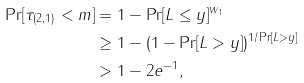Convert formula to latex. <formula><loc_0><loc_0><loc_500><loc_500>\Pr [ \tau _ { ( 2 , 1 ) } < m ] & = 1 - \Pr [ L \leq y ] ^ { w _ { 1 } } \\ & \geq 1 - ( 1 - \Pr [ L > y ] ) ^ { 1 / \Pr [ L > y ] } \\ & > 1 - 2 e ^ { - 1 } ,</formula> 